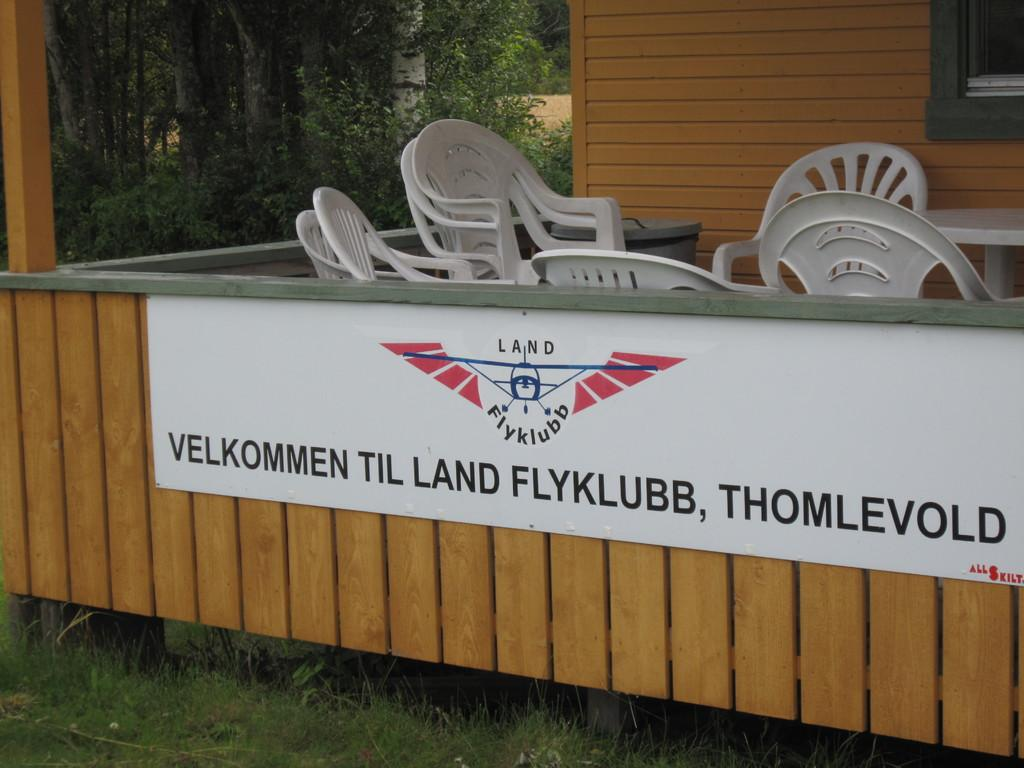What objects are located in the center of the image? There are chairs in the center of the image. What is one of the architectural features visible in the image? There is a wall in the image. What type of vegetation can be seen in the image? There are trees in the image. What is the purpose of the board in the image? The purpose of the board in the image is not specified, but it could be used for displaying information or as a surface for writing or drawing. What allows natural light to enter the space in the image? There is a window in the image that allows natural light to enter the space. What type of ground surface is visible at the bottom of the image? Grass is present at the bottom of the image. What type of jam is being spread on the leg in the image? There is no jam or leg present in the image. What type of steel structure is visible in the image? There is no steel structure visible in the image. 